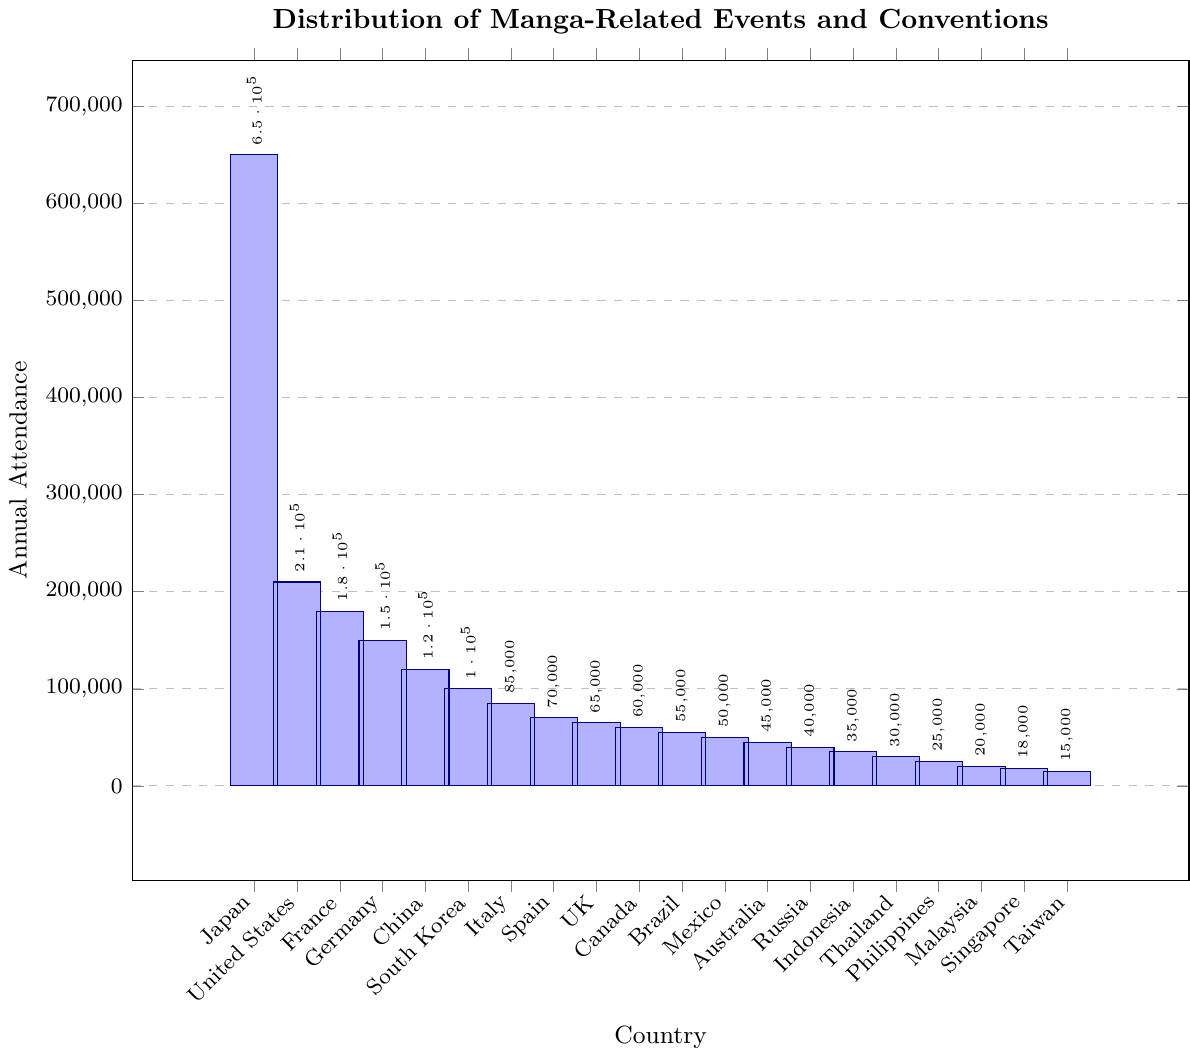What's the country with the highest annual attendance? The figure shows that Japan has the tallest bar among all the countries, indicating the highest attendance.
Answer: Japan Which country has higher attendance: South Korea or China? By comparing the heights of the bars for South Korea and China, we see that China's bar is taller.
Answer: China What is the total annual attendance for the top three countries? Adding the annual attendance figures for Japan (650,000), United States (210,000), and France (180,000) gives the total: 650,000 + 210,000 + 180,000 = 1,040,000.
Answer: 1,040,000 How does the attendance in the United Kingdom compare to that in Canada? The figure shows that the bar for the United Kingdom and Canada are close in height, but the United Kingdom's bar is slightly higher.
Answer: United Kingdom What is the difference in attendance between the country with the highest attendance and the country with the lowest attendance? Japan has the highest attendance with 650,000, and Taiwan has the lowest attendance with 15,000. The difference is 650,000 - 15,000 = 635,000.
Answer: 635,000 Which countries have an annual attendance between 50,000 and 100,000? From the figure, we identify South Korea (100,000), Italy (85,000), Spain (70,000), United Kingdom (65,000), and Canada (60,000) as falling within this range.
Answer: South Korea, Italy, Spain, United Kingdom, Canada If you sum the attendance from countries in Europe (France, Germany, Italy, Spain, United Kingdom), what is the total attendance? Adding the attendance figures for France (180,000), Germany (150,000), Italy (85,000), Spain (70,000), and United Kingdom (65,000) gives: 180,000 + 150,000 + 85,000 + 70,000 + 65,000 = 550,000.
Answer: 550,000 What's the average attendance for the countries with more than 100,000 annual attendees (Japan, United States, France, Germany, China, South Korea)? Summing the attendance figures for these countries: 650,000 (Japan) + 210,000 (United States) + 180,000 (France) + 150,000 (Germany) + 120,000 (China) + 100,000 (South Korea) = 1,410,000. Dividing by the number of countries (6), the average is 1,410,000 / 6 = 235,000.
Answer: 235,000 